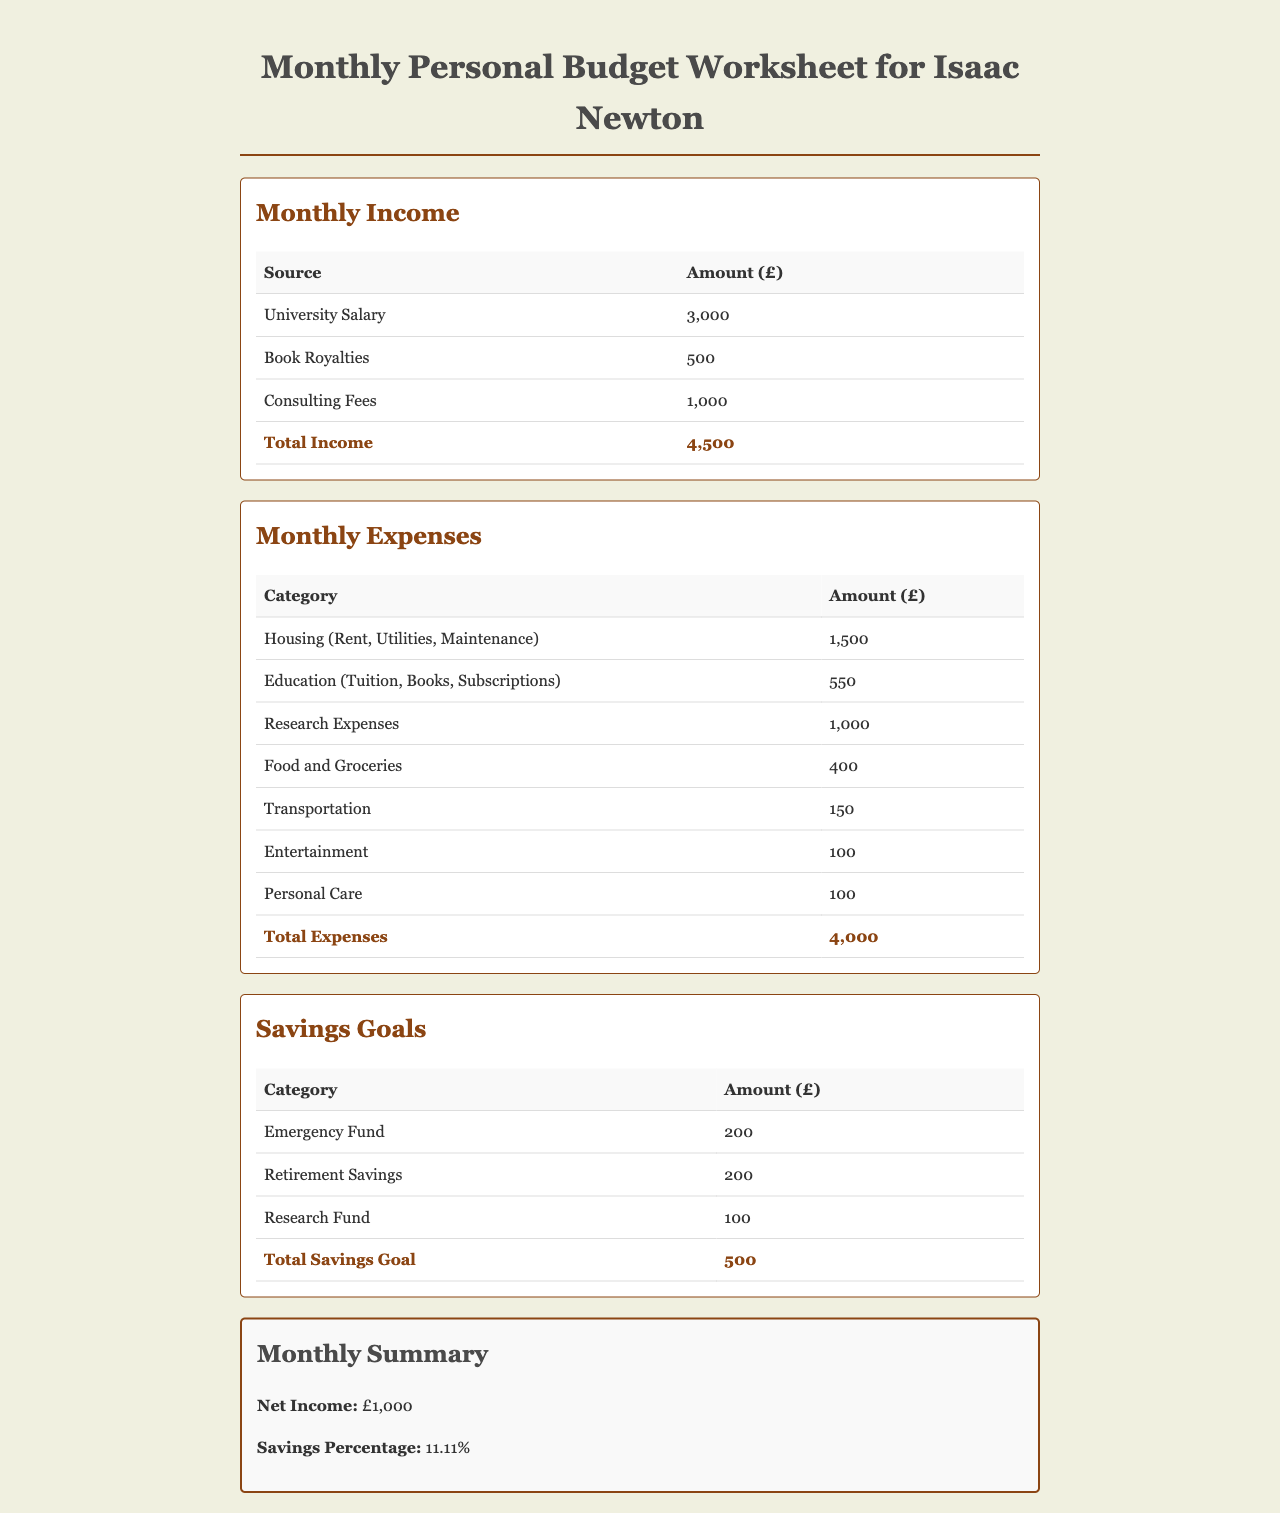What is the total monthly income? The total monthly income is calculated by adding all sources of income: University Salary, Book Royalties, and Consulting Fees, which amounts to £3,000 + £500 + £1,000 = £4,500.
Answer: £4,500 What are the monthly housing expenses? The monthly housing expenses include Rent, Utilities, and Maintenance, which total £1,500.
Answer: £1,500 What is the total amount allocated for research expenses? The total amount for research expenses is explicitly mentioned in the expenses section as £1,000.
Answer: £1,000 What percentage of the income is allocated to savings? The savings percentage is calculated based on the total savings goal divided by the total income, resulting in £500 / £4,500 = approximately 11.11%.
Answer: 11.11% What is the total of all monthly expenses? The total monthly expenses are calculated by adding up all expense categories listed, amounting to £4,000.
Answer: £4,000 What is the net income for the month? The net income is determined by subtracting the total expenses from the total income: £4,500 - £4,000 = £1,000.
Answer: £1,000 How much is allocated for retirement savings? The amount allocated for retirement savings is specifically noted in the savings goals section as £200.
Answer: £200 What is the sum of educational expenses? The sum of educational expenses includes Tuition, Books, and Subscriptions, totaling £550.
Answer: £550 What are the total savings goals for the month? The total savings goals are represented as the sum of all categories under savings, which is £200 + £200 + £100 = £500.
Answer: £500 